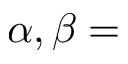<formula> <loc_0><loc_0><loc_500><loc_500>\alpha , \beta =</formula> 